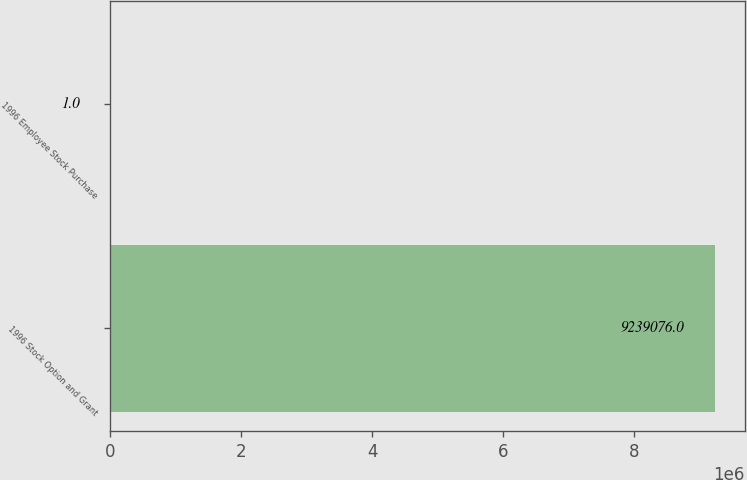Convert chart to OTSL. <chart><loc_0><loc_0><loc_500><loc_500><bar_chart><fcel>1996 Stock Option and Grant<fcel>1996 Employee Stock Purchase<nl><fcel>9.23908e+06<fcel>1<nl></chart> 